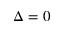Convert formula to latex. <formula><loc_0><loc_0><loc_500><loc_500>\Delta = 0</formula> 